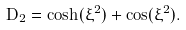Convert formula to latex. <formula><loc_0><loc_0><loc_500><loc_500>D _ { 2 } = \cosh ( \xi ^ { 2 } ) + \cos ( \xi ^ { 2 } ) .</formula> 